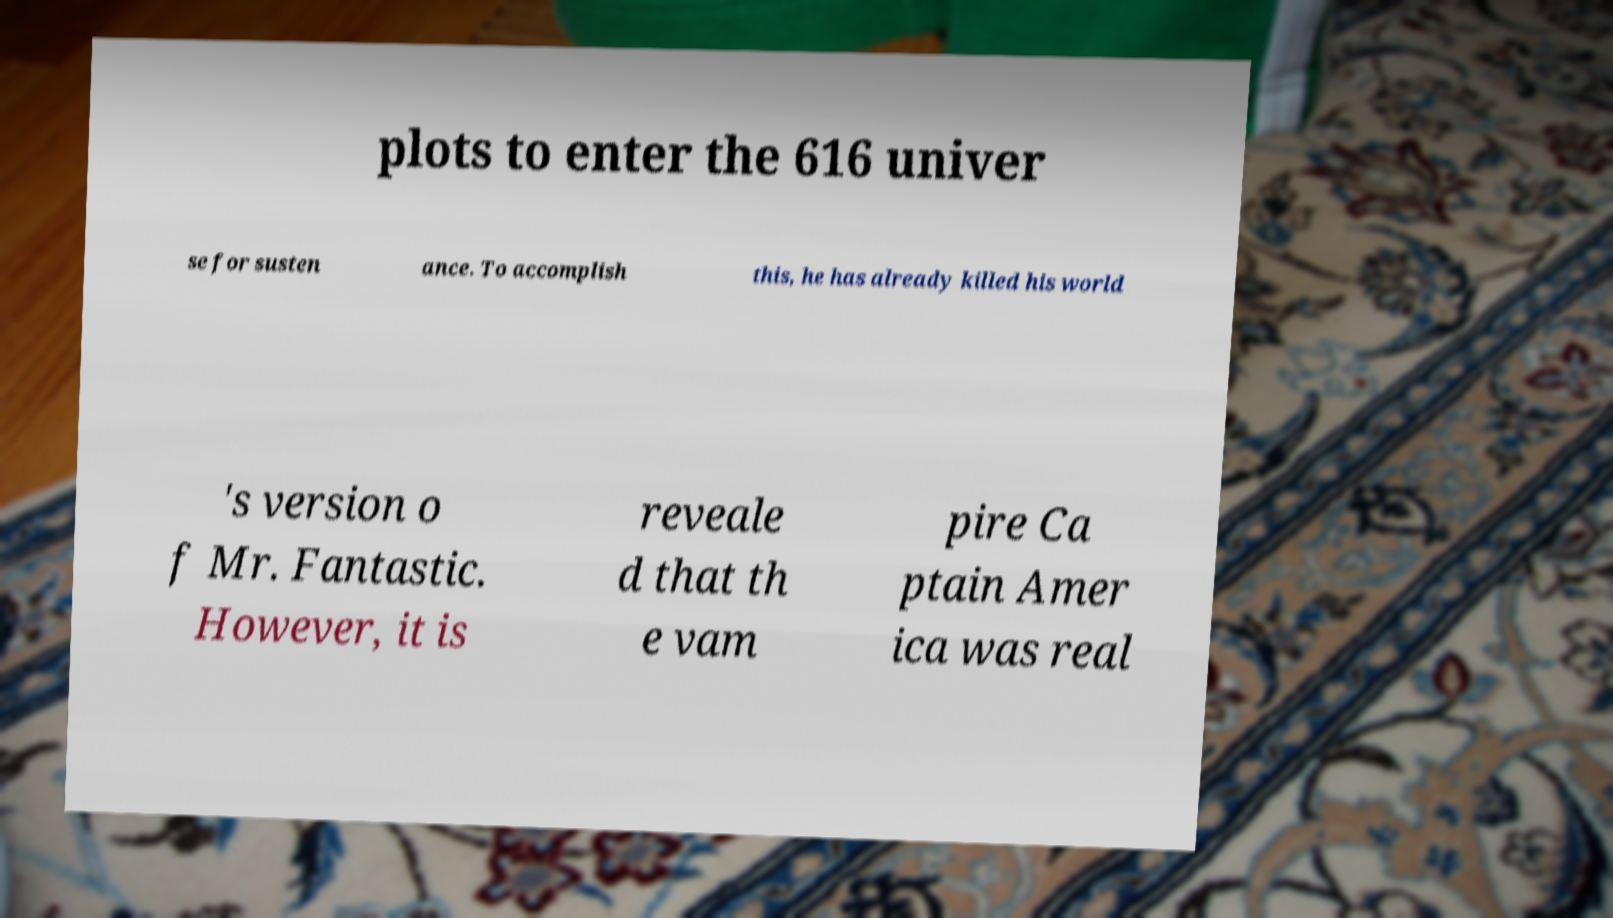Could you assist in decoding the text presented in this image and type it out clearly? plots to enter the 616 univer se for susten ance. To accomplish this, he has already killed his world 's version o f Mr. Fantastic. However, it is reveale d that th e vam pire Ca ptain Amer ica was real 